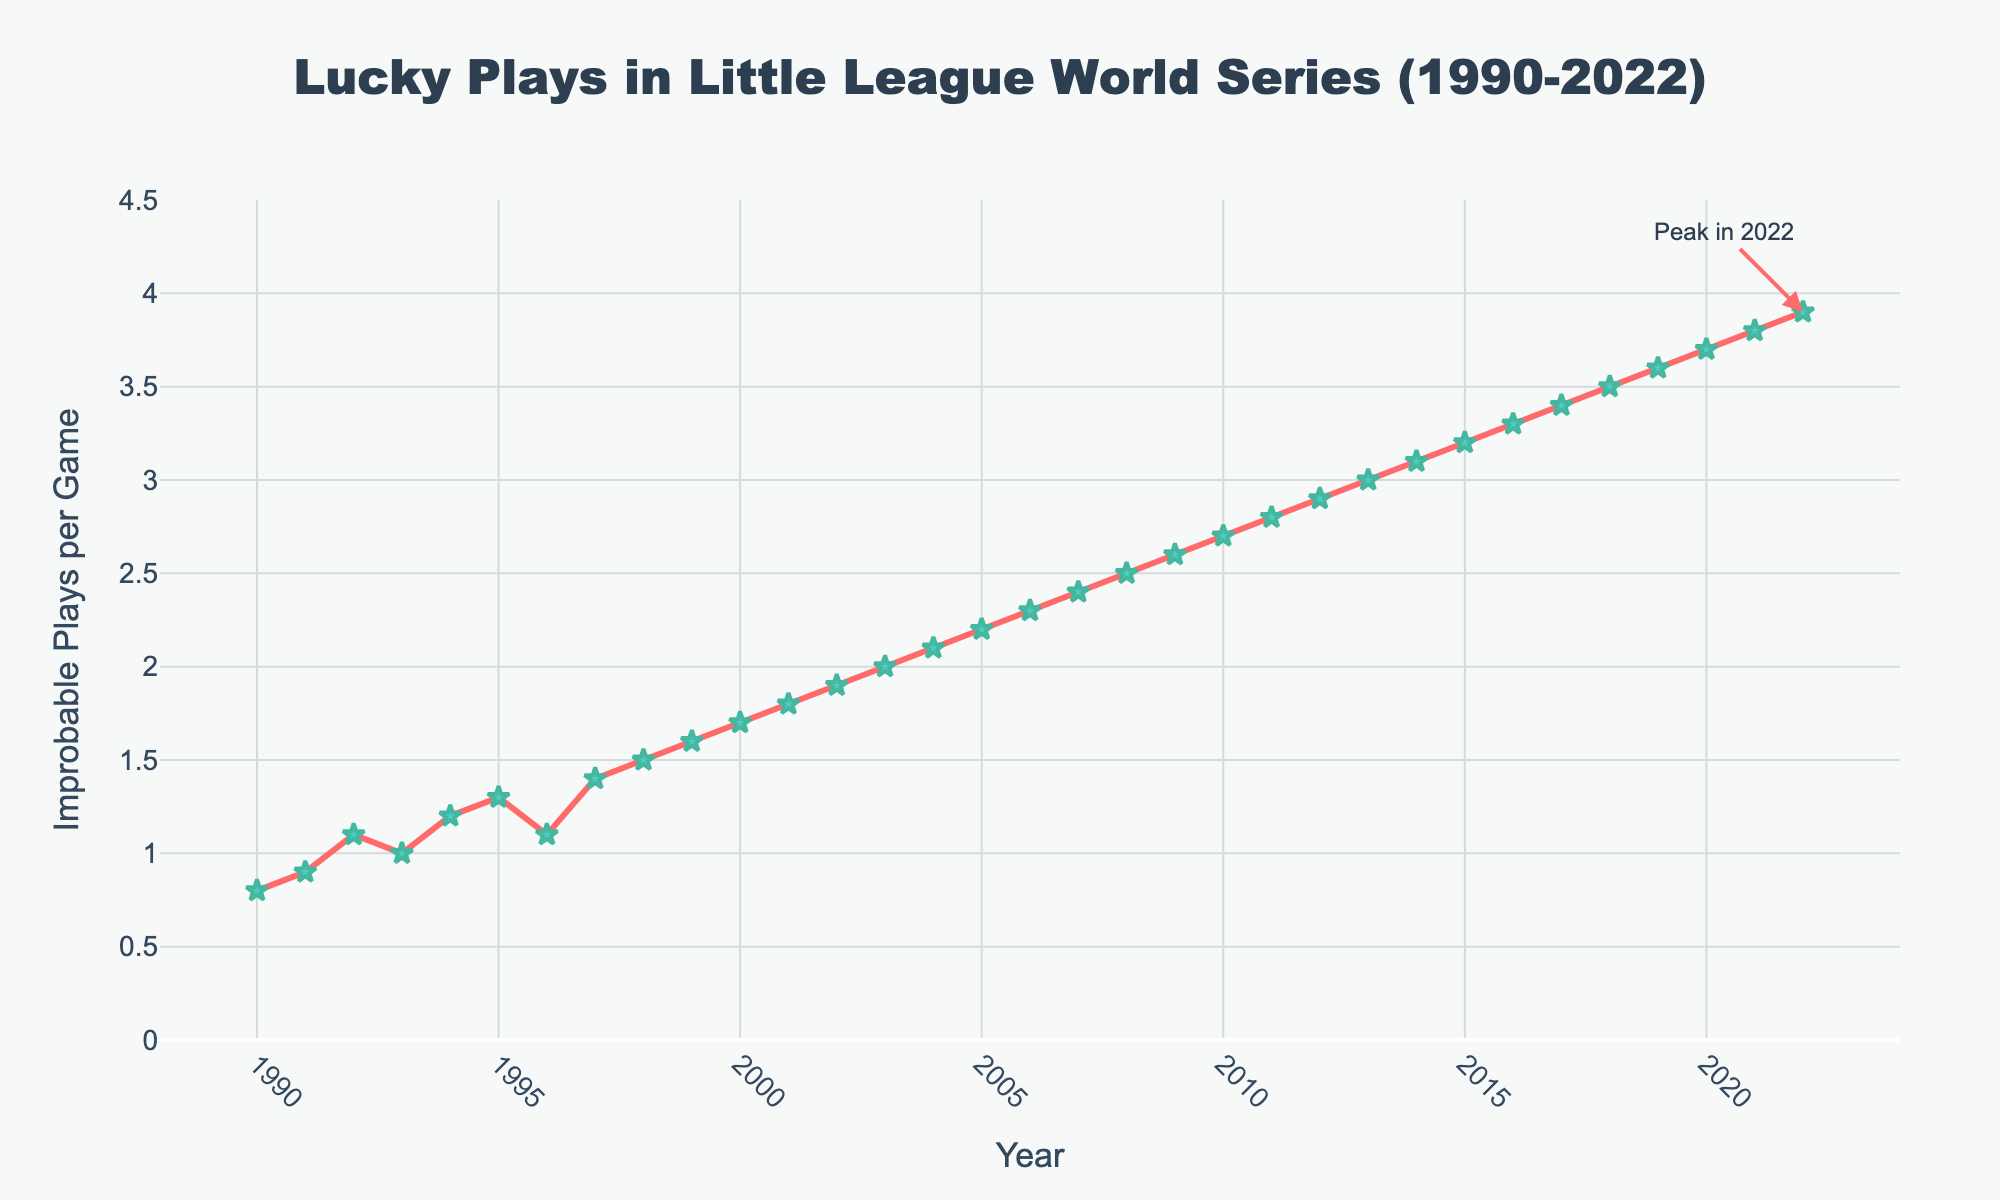what's the overall trend of improbable plays per game from 1990 to 2022? From 1990 to 2022, the line chart shows a consistent upward trend with a gradual increase in the number of improbable plays per game each year.
Answer: Increasing what was the number of improbable plays per game in 2007 and how does it compare to 1990? The improbable plays per game in 2007 were 2.4, which is 1.6 plays higher than in 1990, which had 0.8 plays per game.
Answer: 2.4, 1.6 higher how many years had improbable plays per game greater than or equal to 3? Improbable plays per game reached 3 or more starting from 2013 up to 2022, spanning 10 years in total.
Answer: 10 years what was the average number of improbable plays per game in the decade of the 2010s? To find the average, sum the values from 2010 to 2019 (2.7, 2.8, 2.9, 3.0, 3.1, 3.2, 3.3, 3.4, 3.5, 3.6) which equals 32.5. Then divide by the number of years (10), resulting in an average of 3.25 improbable plays per game.
Answer: 3.25 what's the difference in the number of improbable plays per game between 1995 and 2022? In 1995, there were 1.3 improbable plays per game, and in 2022, there were 3.9. The difference is 3.9 - 1.3 = 2.6 improbable plays per game.
Answer: 2.6 which year shows the largest leap in improbable plays per game compared to the previous year? The largest leap is between 2011 and 2012, where the number of improbable plays per game increased from 2.8 to 2.9.
Answer: 2011-2012 what color line indicates the trend of improbable plays per game? The line indicating the trend is shown in red.
Answer: Red what annotation is added to the figure, and what is its significance? The annotation "Peak in 2022" is added at the top of the chart pointing to 2022, highlighting the highest value of improbable plays per game in the entire span covered by the chart.
Answer: Peak in 2022 what’s the range of improbable plays per game covered in the y-axis? The y-axis covers a range from 0 to 4.5, providing a comprehensive view of the improbable plays from the lowest to the highest values observed.
Answer: 0 to 4.5 